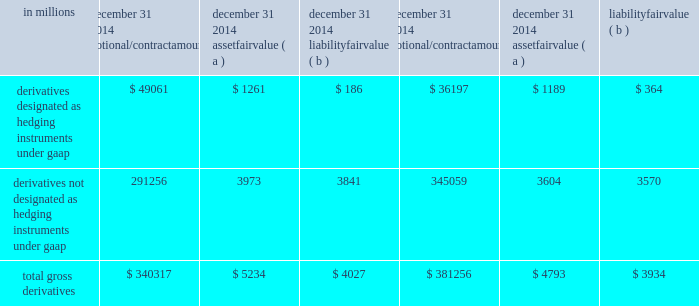Note 15 financial derivatives we use derivative financial instruments ( derivatives ) primarily to help manage exposure to interest rate , market and credit risk and reduce the effects that changes in interest rates may have on net income , the fair value of assets and liabilities , and cash flows .
We also enter into derivatives with customers to facilitate their risk management activities .
Derivatives represent contracts between parties that usually require little or no initial net investment and result in one party delivering cash or another type of asset to the other party based on a notional amount and an underlying as specified in the contract .
Derivative transactions are often measured in terms of notional amount , but this amount is generally not exchanged and it is not recorded on the balance sheet .
The notional amount is the basis to which the underlying is applied to determine required payments under the derivative contract .
The underlying is a referenced interest rate ( commonly libor ) , security price , credit spread or other index .
Residential and commercial real estate loan commitments associated with loans to be sold also qualify as derivative instruments .
The table presents the notional amounts and gross fair values of all derivative assets and liabilities held by pnc : table 124 : total gross derivatives .
( a ) included in other assets on our consolidated balance sheet .
( b ) included in other liabilities on our consolidated balance sheet .
All derivatives are carried on our consolidated balance sheet at fair value .
Derivative balances are presented on the consolidated balance sheet on a net basis taking into consideration the effects of legally enforceable master netting agreements and any related cash collateral exchanged with counterparties .
Further discussion regarding the rights of setoff associated with these legally enforceable master netting agreements is included in the offsetting , counterparty credit risk , and contingent features section below .
Our exposure related to risk participations where we sold protection is discussed in the credit derivatives section below .
Any nonperformance risk , including credit risk , is included in the determination of the estimated net fair value of the derivatives .
Further discussion on how derivatives are accounted for is included in note 1 accounting policies .
Derivatives designated as hedging instruments under gaap certain derivatives used to manage interest rate and foreign exchange risk as part of our asset and liability risk management activities are designated as accounting hedges under gaap .
Derivatives hedging the risks associated with changes in the fair value of assets or liabilities are considered fair value hedges , derivatives hedging the variability of expected future cash flows are considered cash flow hedges , and derivatives hedging a net investment in a foreign subsidiary are considered net investment hedges .
Designating derivatives as accounting hedges allows for gains and losses on those derivatives , to the extent effective , to be recognized in the income statement in the same period the hedged items affect earnings .
The pnc financial services group , inc .
2013 form 10-k 187 .
What percentage of notional contract amount of total gross derivatives at december 31 , 2014 was from derivatives not designated as hedging instruments under gaap? 
Computations: (291256 / 340317)
Answer: 0.85584. 